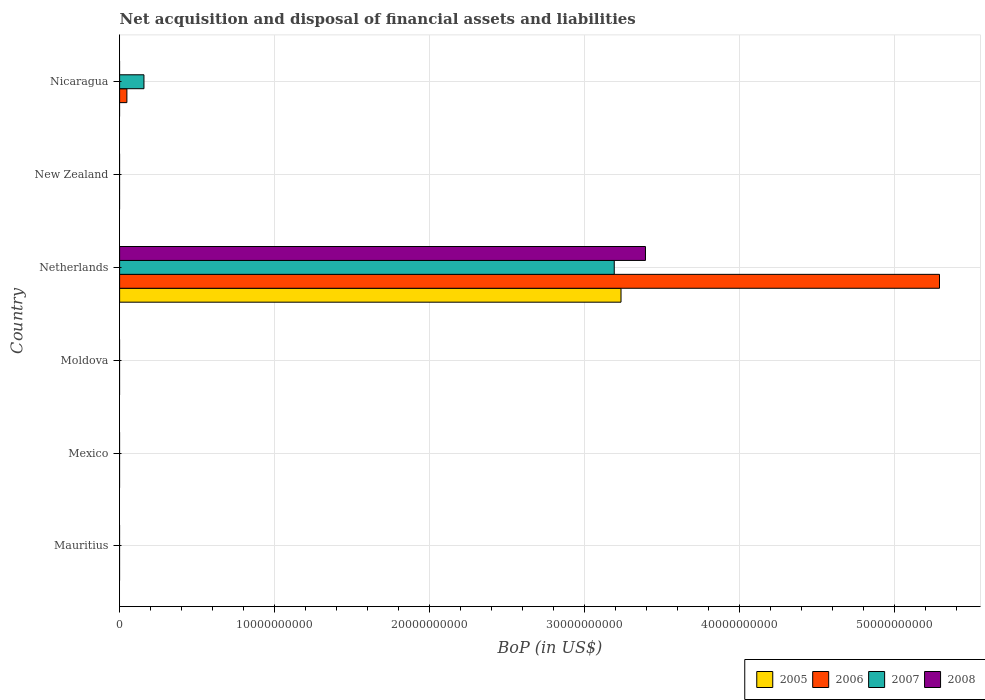How many different coloured bars are there?
Your answer should be compact. 4. Are the number of bars on each tick of the Y-axis equal?
Provide a short and direct response. No. How many bars are there on the 2nd tick from the top?
Give a very brief answer. 0. How many bars are there on the 3rd tick from the bottom?
Make the answer very short. 0. What is the label of the 1st group of bars from the top?
Your answer should be compact. Nicaragua. What is the Balance of Payments in 2006 in Nicaragua?
Ensure brevity in your answer.  4.71e+08. Across all countries, what is the maximum Balance of Payments in 2006?
Your answer should be very brief. 5.29e+1. In which country was the Balance of Payments in 2008 maximum?
Your answer should be compact. Netherlands. What is the total Balance of Payments in 2008 in the graph?
Your answer should be very brief. 3.39e+1. What is the difference between the Balance of Payments in 2007 in Moldova and the Balance of Payments in 2008 in New Zealand?
Offer a very short reply. 0. What is the average Balance of Payments in 2008 per country?
Offer a very short reply. 5.66e+09. What is the difference between the Balance of Payments in 2007 and Balance of Payments in 2005 in Netherlands?
Offer a very short reply. -4.36e+08. In how many countries, is the Balance of Payments in 2006 greater than 32000000000 US$?
Provide a succinct answer. 1. What is the difference between the highest and the lowest Balance of Payments in 2007?
Offer a very short reply. 3.19e+1. In how many countries, is the Balance of Payments in 2005 greater than the average Balance of Payments in 2005 taken over all countries?
Give a very brief answer. 1. Is it the case that in every country, the sum of the Balance of Payments in 2005 and Balance of Payments in 2006 is greater than the sum of Balance of Payments in 2007 and Balance of Payments in 2008?
Give a very brief answer. No. Are all the bars in the graph horizontal?
Make the answer very short. Yes. Does the graph contain any zero values?
Give a very brief answer. Yes. Does the graph contain grids?
Your answer should be very brief. Yes. How many legend labels are there?
Provide a succinct answer. 4. What is the title of the graph?
Your response must be concise. Net acquisition and disposal of financial assets and liabilities. Does "1992" appear as one of the legend labels in the graph?
Your answer should be compact. No. What is the label or title of the X-axis?
Offer a very short reply. BoP (in US$). What is the BoP (in US$) of 2005 in Mauritius?
Ensure brevity in your answer.  0. What is the BoP (in US$) of 2007 in Mauritius?
Your answer should be compact. 0. What is the BoP (in US$) of 2005 in Mexico?
Ensure brevity in your answer.  0. What is the BoP (in US$) in 2005 in Moldova?
Provide a short and direct response. 0. What is the BoP (in US$) of 2007 in Moldova?
Provide a short and direct response. 0. What is the BoP (in US$) in 2008 in Moldova?
Give a very brief answer. 0. What is the BoP (in US$) in 2005 in Netherlands?
Your answer should be very brief. 3.24e+1. What is the BoP (in US$) of 2006 in Netherlands?
Your response must be concise. 5.29e+1. What is the BoP (in US$) of 2007 in Netherlands?
Offer a very short reply. 3.19e+1. What is the BoP (in US$) of 2008 in Netherlands?
Provide a short and direct response. 3.39e+1. What is the BoP (in US$) of 2005 in New Zealand?
Provide a short and direct response. 0. What is the BoP (in US$) of 2006 in New Zealand?
Offer a very short reply. 0. What is the BoP (in US$) of 2007 in New Zealand?
Provide a short and direct response. 0. What is the BoP (in US$) in 2008 in New Zealand?
Your answer should be very brief. 0. What is the BoP (in US$) in 2005 in Nicaragua?
Make the answer very short. 0. What is the BoP (in US$) of 2006 in Nicaragua?
Your response must be concise. 4.71e+08. What is the BoP (in US$) of 2007 in Nicaragua?
Offer a terse response. 1.57e+09. Across all countries, what is the maximum BoP (in US$) of 2005?
Your answer should be compact. 3.24e+1. Across all countries, what is the maximum BoP (in US$) of 2006?
Offer a terse response. 5.29e+1. Across all countries, what is the maximum BoP (in US$) in 2007?
Your response must be concise. 3.19e+1. Across all countries, what is the maximum BoP (in US$) of 2008?
Provide a succinct answer. 3.39e+1. Across all countries, what is the minimum BoP (in US$) of 2006?
Offer a very short reply. 0. Across all countries, what is the minimum BoP (in US$) in 2007?
Ensure brevity in your answer.  0. Across all countries, what is the minimum BoP (in US$) of 2008?
Provide a short and direct response. 0. What is the total BoP (in US$) of 2005 in the graph?
Keep it short and to the point. 3.24e+1. What is the total BoP (in US$) in 2006 in the graph?
Provide a short and direct response. 5.34e+1. What is the total BoP (in US$) in 2007 in the graph?
Offer a very short reply. 3.35e+1. What is the total BoP (in US$) of 2008 in the graph?
Give a very brief answer. 3.39e+1. What is the difference between the BoP (in US$) in 2006 in Netherlands and that in Nicaragua?
Offer a terse response. 5.24e+1. What is the difference between the BoP (in US$) of 2007 in Netherlands and that in Nicaragua?
Your answer should be compact. 3.03e+1. What is the difference between the BoP (in US$) of 2005 in Netherlands and the BoP (in US$) of 2006 in Nicaragua?
Your answer should be compact. 3.19e+1. What is the difference between the BoP (in US$) in 2005 in Netherlands and the BoP (in US$) in 2007 in Nicaragua?
Provide a short and direct response. 3.08e+1. What is the difference between the BoP (in US$) of 2006 in Netherlands and the BoP (in US$) of 2007 in Nicaragua?
Offer a very short reply. 5.13e+1. What is the average BoP (in US$) in 2005 per country?
Give a very brief answer. 5.39e+09. What is the average BoP (in US$) in 2006 per country?
Offer a very short reply. 8.90e+09. What is the average BoP (in US$) of 2007 per country?
Ensure brevity in your answer.  5.58e+09. What is the average BoP (in US$) in 2008 per country?
Ensure brevity in your answer.  5.66e+09. What is the difference between the BoP (in US$) of 2005 and BoP (in US$) of 2006 in Netherlands?
Make the answer very short. -2.06e+1. What is the difference between the BoP (in US$) in 2005 and BoP (in US$) in 2007 in Netherlands?
Provide a succinct answer. 4.36e+08. What is the difference between the BoP (in US$) in 2005 and BoP (in US$) in 2008 in Netherlands?
Ensure brevity in your answer.  -1.58e+09. What is the difference between the BoP (in US$) of 2006 and BoP (in US$) of 2007 in Netherlands?
Ensure brevity in your answer.  2.10e+1. What is the difference between the BoP (in US$) of 2006 and BoP (in US$) of 2008 in Netherlands?
Your answer should be compact. 1.90e+1. What is the difference between the BoP (in US$) in 2007 and BoP (in US$) in 2008 in Netherlands?
Offer a very short reply. -2.01e+09. What is the difference between the BoP (in US$) of 2006 and BoP (in US$) of 2007 in Nicaragua?
Keep it short and to the point. -1.10e+09. What is the ratio of the BoP (in US$) in 2006 in Netherlands to that in Nicaragua?
Your answer should be compact. 112.4. What is the ratio of the BoP (in US$) of 2007 in Netherlands to that in Nicaragua?
Give a very brief answer. 20.31. What is the difference between the highest and the lowest BoP (in US$) in 2005?
Ensure brevity in your answer.  3.24e+1. What is the difference between the highest and the lowest BoP (in US$) in 2006?
Ensure brevity in your answer.  5.29e+1. What is the difference between the highest and the lowest BoP (in US$) of 2007?
Keep it short and to the point. 3.19e+1. What is the difference between the highest and the lowest BoP (in US$) in 2008?
Your response must be concise. 3.39e+1. 